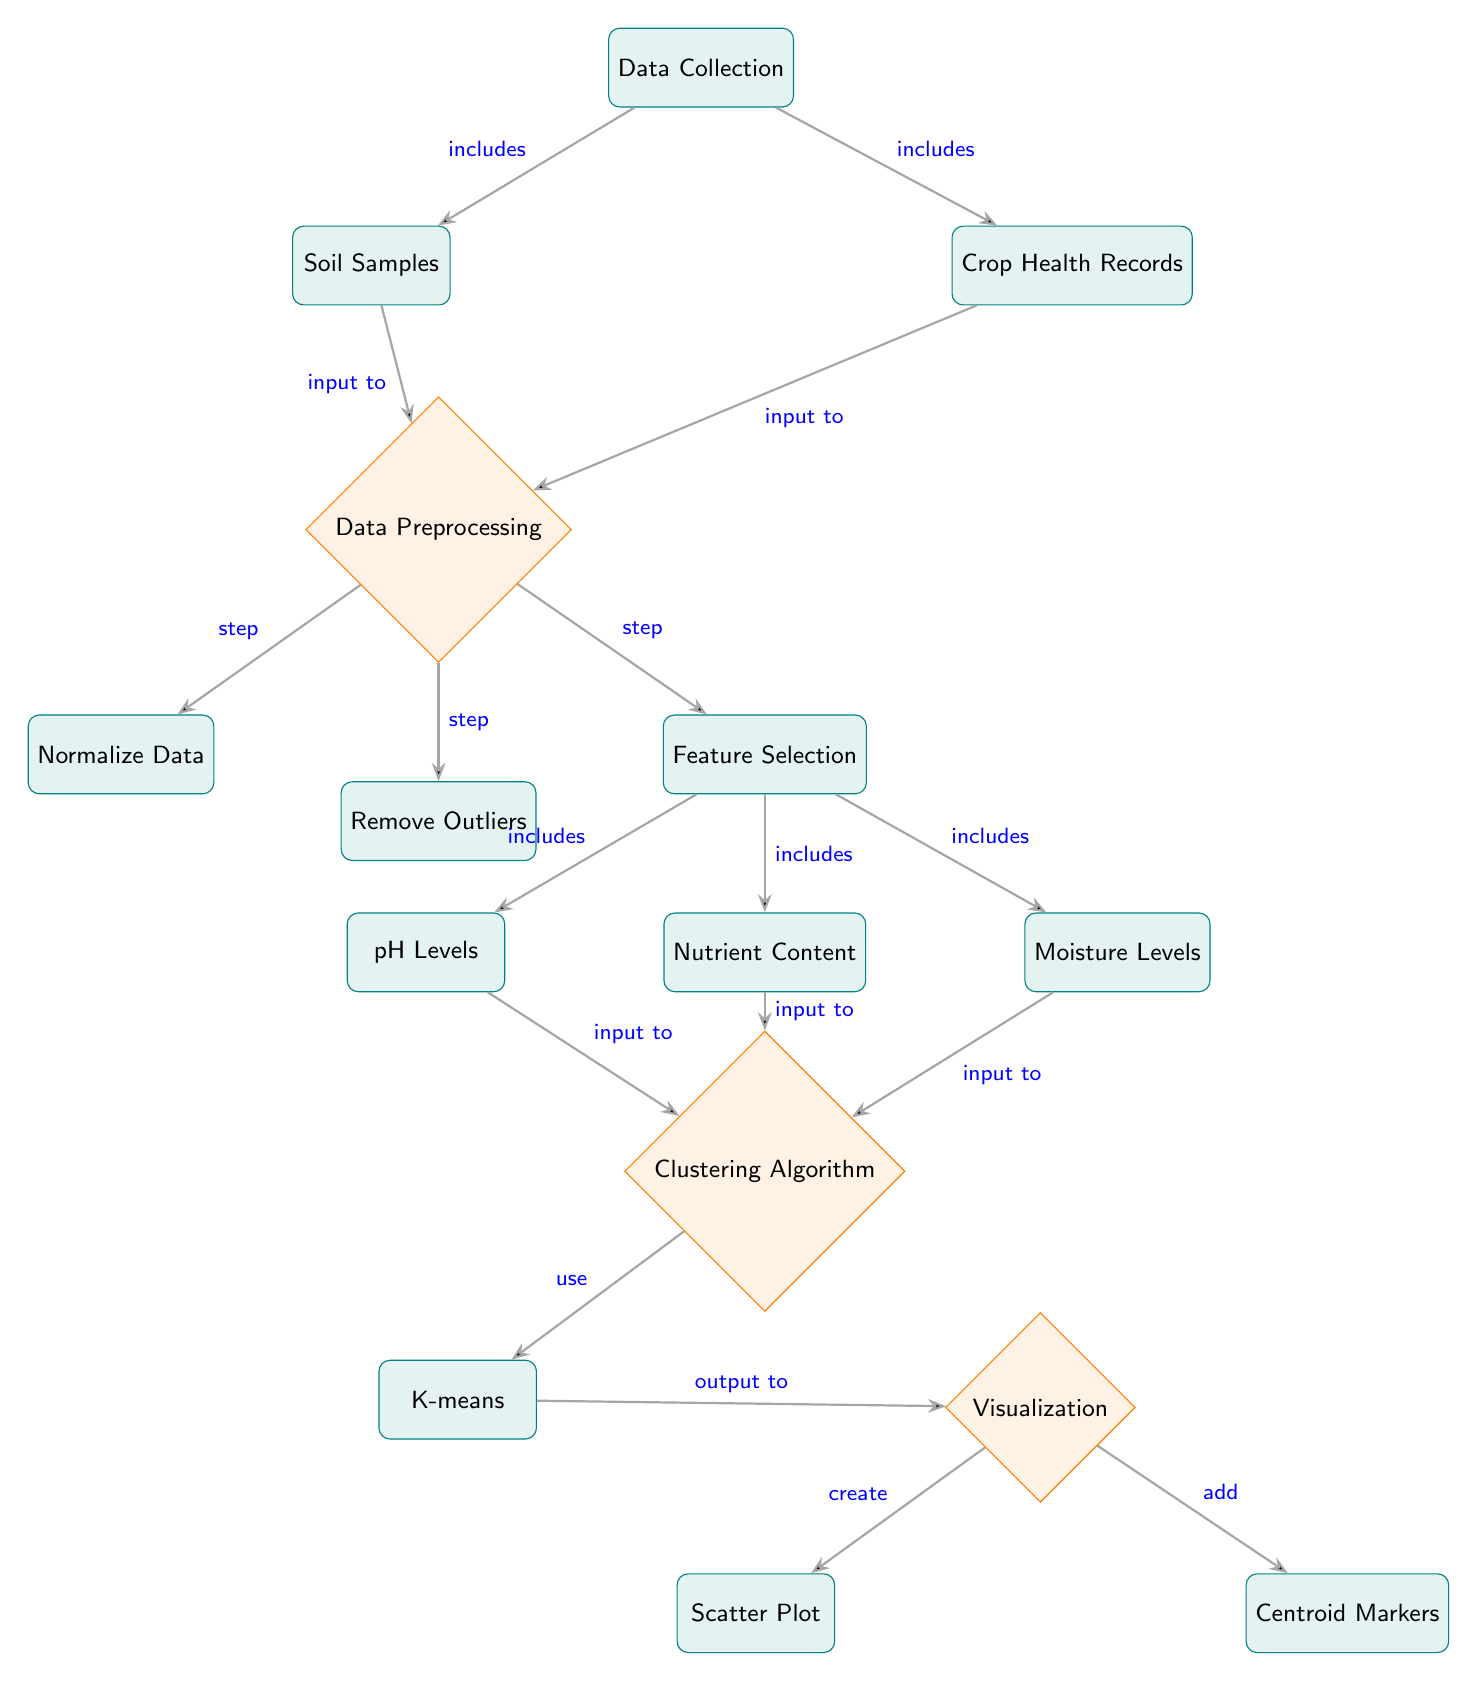What are the two main data sources for the diagram? The diagram indicates that the two main data sources are soil samples and crop health records, which are both included under data collection.
Answer: Soil Samples, Crop Health Records What is the first step after data collection? According to the diagram, the first step after collecting data is data preprocessing, which follows directly from the data collection node.
Answer: Data Preprocessing How many features are included under feature selection? The diagram shows three features under feature selection: pH Levels, Nutrient Content, and Moisture Levels. Therefore, the total number of features is three.
Answer: Three Which clustering algorithm is used in the diagram? The diagram specifies that the clustering algorithm used is K-means, represented in the node labeled as such under the clustering algorithm section.
Answer: K-means What are the outputs of the clustering algorithm? The outputs of the clustering algorithm as shown in the diagram are visualizations, specifically a scatter plot and centroid markers.
Answer: Scatter Plot, Centroid Markers What is the purpose of the visualization step? The visualization step provides a way to create a scatter plot and add centroid markers, which help illustrate the results of the clustering process visually.
Answer: To illustrate clustering results Which data nodes provide input to the clustering algorithm? The diagram indicates that the clustering algorithm receives input from pH Levels, Nutrient Content, and Moisture Levels, which are all connected to the clustering algorithm node.
Answer: pH Levels, Nutrient Content, Moisture Levels What comes after the normalization of data step? The diagram shows that after the normalization of data step, there is another step labeled remove outliers, which is part of the data preprocessing process.
Answer: Remove Outliers 